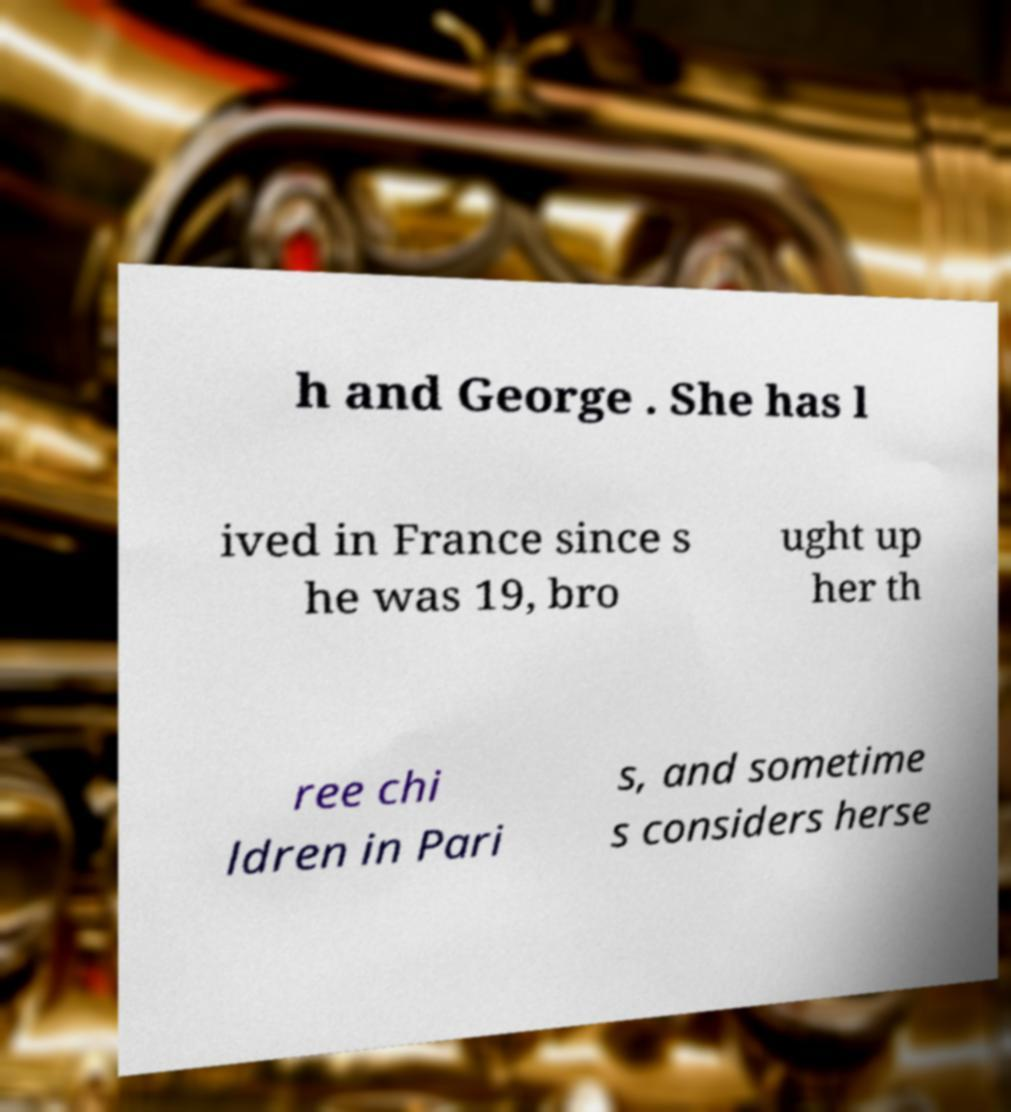Can you accurately transcribe the text from the provided image for me? h and George . She has l ived in France since s he was 19, bro ught up her th ree chi ldren in Pari s, and sometime s considers herse 